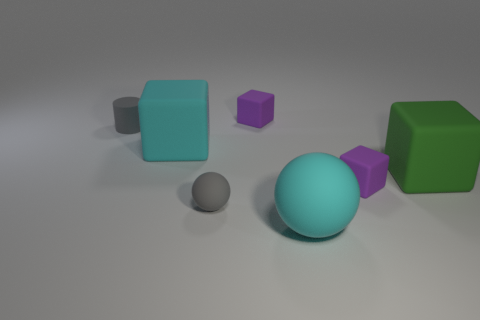The matte object that is the same color as the small ball is what shape?
Keep it short and to the point. Cylinder. What number of other things are the same material as the large sphere?
Give a very brief answer. 6. How many gray things are either big matte spheres or cylinders?
Your response must be concise. 1. The rubber thing that is the same color as the small matte cylinder is what size?
Offer a very short reply. Small. What number of rubber balls are behind the tiny matte sphere?
Offer a very short reply. 0. There is a purple block that is right of the rubber block that is behind the cyan matte thing behind the green thing; how big is it?
Make the answer very short. Small. Is there a tiny cube that is behind the gray ball that is in front of the cyan rubber object that is behind the large rubber ball?
Ensure brevity in your answer.  Yes. Is the number of green rubber things greater than the number of large green cylinders?
Your response must be concise. Yes. What is the color of the tiny rubber cylinder that is to the left of the large green thing?
Your response must be concise. Gray. Is the number of cubes in front of the green rubber object greater than the number of tiny metallic cylinders?
Provide a short and direct response. Yes. 